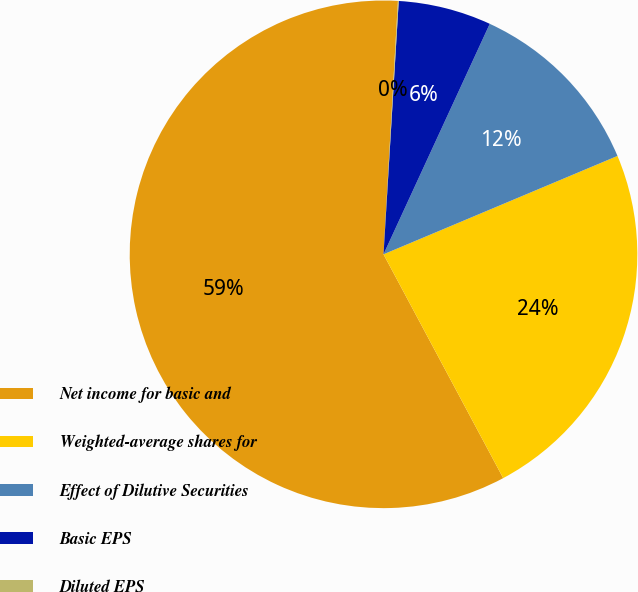Convert chart to OTSL. <chart><loc_0><loc_0><loc_500><loc_500><pie_chart><fcel>Net income for basic and<fcel>Weighted-average shares for<fcel>Effect of Dilutive Securities<fcel>Basic EPS<fcel>Diluted EPS<nl><fcel>58.72%<fcel>23.52%<fcel>11.79%<fcel>5.92%<fcel>0.05%<nl></chart> 